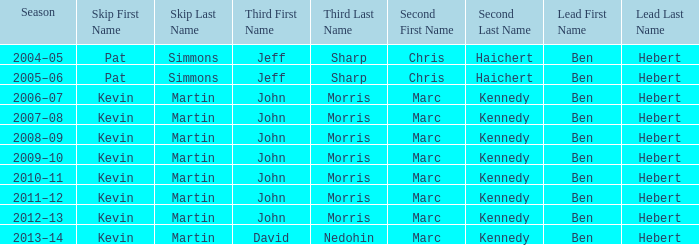What lead has the third David Nedohin? Ben Hebert. 